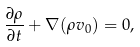<formula> <loc_0><loc_0><loc_500><loc_500>\frac { \partial \rho } { \partial t } + \nabla ( \rho v _ { 0 } ) = 0 ,</formula> 